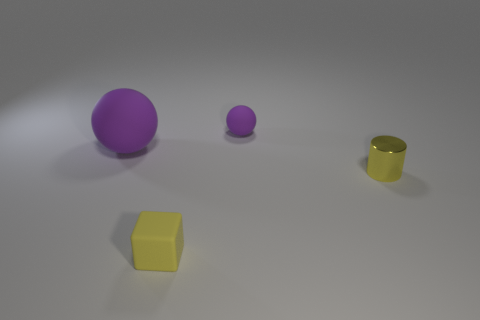If you had to guess, what material is the floor made of? Judging by the smooth appearance and the way the light reflects off the surface, the floor resembles a polished concrete or a matte, unpolished stone, giving it a sleek, contemporary aesthetic. 